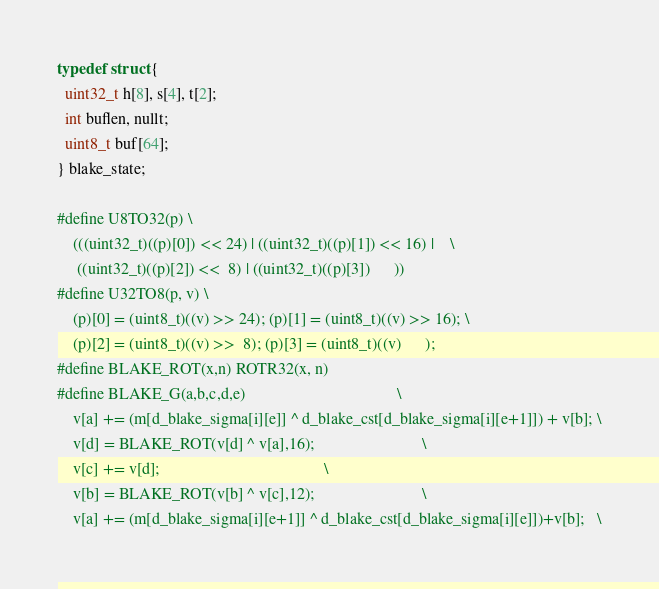Convert code to text. <code><loc_0><loc_0><loc_500><loc_500><_Cuda_>
typedef struct {
  uint32_t h[8], s[4], t[2];
  int buflen, nullt;
  uint8_t buf[64];
} blake_state;

#define U8TO32(p) \
    (((uint32_t)((p)[0]) << 24) | ((uint32_t)((p)[1]) << 16) |    \
     ((uint32_t)((p)[2]) <<  8) | ((uint32_t)((p)[3])      ))
#define U32TO8(p, v) \
    (p)[0] = (uint8_t)((v) >> 24); (p)[1] = (uint8_t)((v) >> 16); \
    (p)[2] = (uint8_t)((v) >>  8); (p)[3] = (uint8_t)((v)      );
#define BLAKE_ROT(x,n) ROTR32(x, n)
#define BLAKE_G(a,b,c,d,e)                                      \
    v[a] += (m[d_blake_sigma[i][e]] ^ d_blake_cst[d_blake_sigma[i][e+1]]) + v[b]; \
    v[d] = BLAKE_ROT(v[d] ^ v[a],16);                           \
    v[c] += v[d];                                         \
    v[b] = BLAKE_ROT(v[b] ^ v[c],12);                           \
    v[a] += (m[d_blake_sigma[i][e+1]] ^ d_blake_cst[d_blake_sigma[i][e]])+v[b];   \</code> 